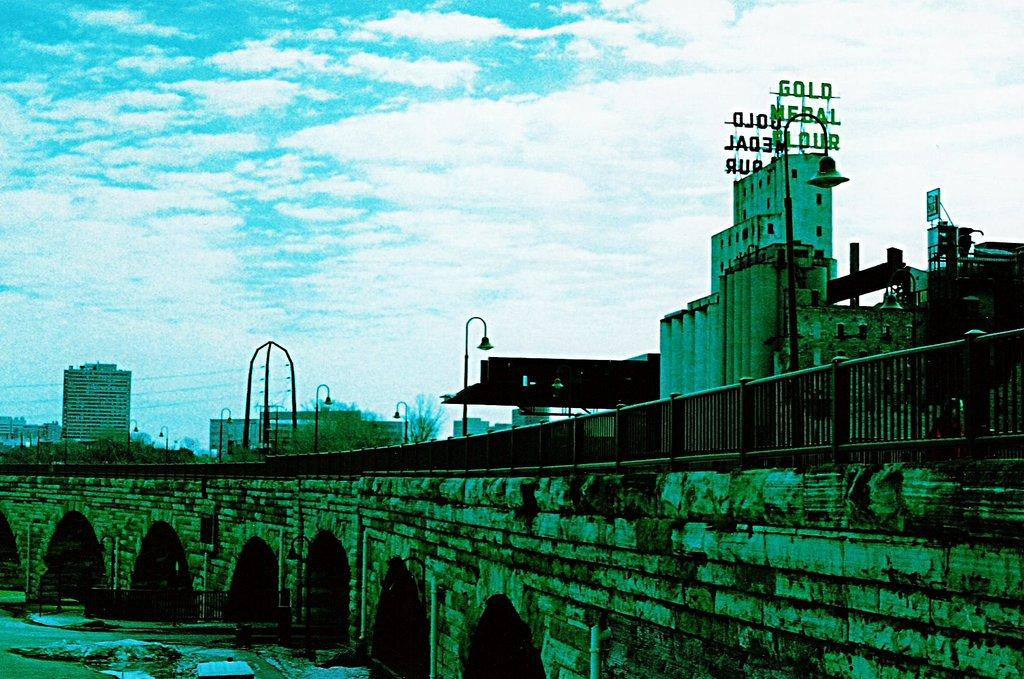What type of structure can be seen in the image? There is a bridge in the image. What else can be seen in the image besides the bridge? There are buildings, trees, light poles, and a railing in the image. What are the pipes used for in the image? The purpose of the pipes in the image is not specified, but they are likely part of the infrastructure. What is visible in the sky in the image? The sky is visible in the image, and clouds are present. What type of net is being used to catch fish in the image? There is no net or fish present in the image; it features a bridge, buildings, trees, light poles, a railing, pipes, and a sky with clouds. 